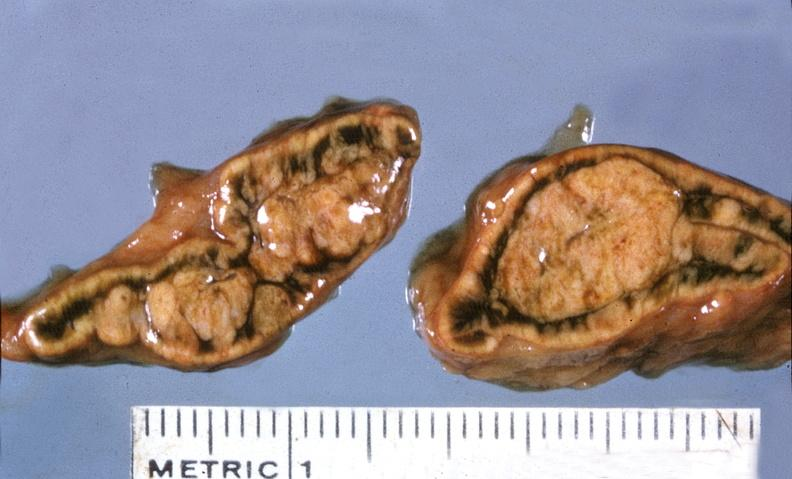s lower chest and abdomen anterior present?
Answer the question using a single word or phrase. No 